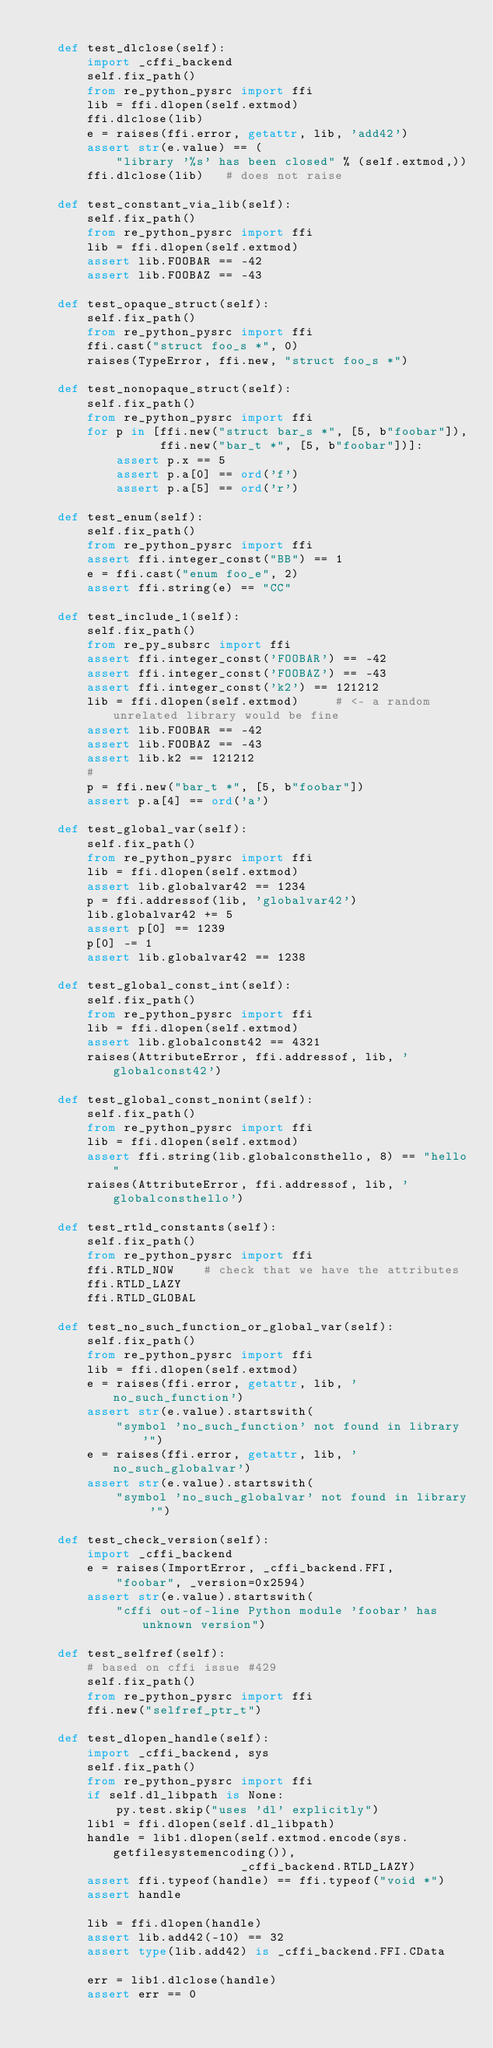Convert code to text. <code><loc_0><loc_0><loc_500><loc_500><_Python_>
    def test_dlclose(self):
        import _cffi_backend
        self.fix_path()
        from re_python_pysrc import ffi
        lib = ffi.dlopen(self.extmod)
        ffi.dlclose(lib)
        e = raises(ffi.error, getattr, lib, 'add42')
        assert str(e.value) == (
            "library '%s' has been closed" % (self.extmod,))
        ffi.dlclose(lib)   # does not raise

    def test_constant_via_lib(self):
        self.fix_path()
        from re_python_pysrc import ffi
        lib = ffi.dlopen(self.extmod)
        assert lib.FOOBAR == -42
        assert lib.FOOBAZ == -43

    def test_opaque_struct(self):
        self.fix_path()
        from re_python_pysrc import ffi
        ffi.cast("struct foo_s *", 0)
        raises(TypeError, ffi.new, "struct foo_s *")

    def test_nonopaque_struct(self):
        self.fix_path()
        from re_python_pysrc import ffi
        for p in [ffi.new("struct bar_s *", [5, b"foobar"]),
                  ffi.new("bar_t *", [5, b"foobar"])]:
            assert p.x == 5
            assert p.a[0] == ord('f')
            assert p.a[5] == ord('r')

    def test_enum(self):
        self.fix_path()
        from re_python_pysrc import ffi
        assert ffi.integer_const("BB") == 1
        e = ffi.cast("enum foo_e", 2)
        assert ffi.string(e) == "CC"

    def test_include_1(self):
        self.fix_path()
        from re_py_subsrc import ffi
        assert ffi.integer_const('FOOBAR') == -42
        assert ffi.integer_const('FOOBAZ') == -43
        assert ffi.integer_const('k2') == 121212
        lib = ffi.dlopen(self.extmod)     # <- a random unrelated library would be fine
        assert lib.FOOBAR == -42
        assert lib.FOOBAZ == -43
        assert lib.k2 == 121212
        #
        p = ffi.new("bar_t *", [5, b"foobar"])
        assert p.a[4] == ord('a')

    def test_global_var(self):
        self.fix_path()
        from re_python_pysrc import ffi
        lib = ffi.dlopen(self.extmod)
        assert lib.globalvar42 == 1234
        p = ffi.addressof(lib, 'globalvar42')
        lib.globalvar42 += 5
        assert p[0] == 1239
        p[0] -= 1
        assert lib.globalvar42 == 1238

    def test_global_const_int(self):
        self.fix_path()
        from re_python_pysrc import ffi
        lib = ffi.dlopen(self.extmod)
        assert lib.globalconst42 == 4321
        raises(AttributeError, ffi.addressof, lib, 'globalconst42')

    def test_global_const_nonint(self):
        self.fix_path()
        from re_python_pysrc import ffi
        lib = ffi.dlopen(self.extmod)
        assert ffi.string(lib.globalconsthello, 8) == "hello"
        raises(AttributeError, ffi.addressof, lib, 'globalconsthello')

    def test_rtld_constants(self):
        self.fix_path()
        from re_python_pysrc import ffi
        ffi.RTLD_NOW    # check that we have the attributes
        ffi.RTLD_LAZY
        ffi.RTLD_GLOBAL

    def test_no_such_function_or_global_var(self):
        self.fix_path()
        from re_python_pysrc import ffi
        lib = ffi.dlopen(self.extmod)
        e = raises(ffi.error, getattr, lib, 'no_such_function')
        assert str(e.value).startswith(
            "symbol 'no_such_function' not found in library '")
        e = raises(ffi.error, getattr, lib, 'no_such_globalvar')
        assert str(e.value).startswith(
            "symbol 'no_such_globalvar' not found in library '")

    def test_check_version(self):
        import _cffi_backend
        e = raises(ImportError, _cffi_backend.FFI,
            "foobar", _version=0x2594)
        assert str(e.value).startswith(
            "cffi out-of-line Python module 'foobar' has unknown version")

    def test_selfref(self):
        # based on cffi issue #429
        self.fix_path()
        from re_python_pysrc import ffi
        ffi.new("selfref_ptr_t")

    def test_dlopen_handle(self):
        import _cffi_backend, sys
        self.fix_path()
        from re_python_pysrc import ffi
        if self.dl_libpath is None:
            py.test.skip("uses 'dl' explicitly")
        lib1 = ffi.dlopen(self.dl_libpath)
        handle = lib1.dlopen(self.extmod.encode(sys.getfilesystemencoding()),
                             _cffi_backend.RTLD_LAZY)
        assert ffi.typeof(handle) == ffi.typeof("void *")
        assert handle

        lib = ffi.dlopen(handle)
        assert lib.add42(-10) == 32
        assert type(lib.add42) is _cffi_backend.FFI.CData

        err = lib1.dlclose(handle)
        assert err == 0
</code> 